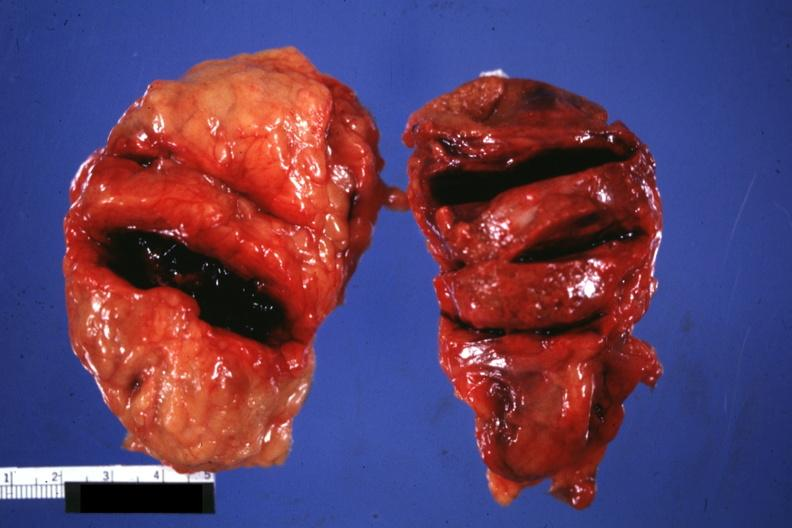s adrenal present?
Answer the question using a single word or phrase. Yes 